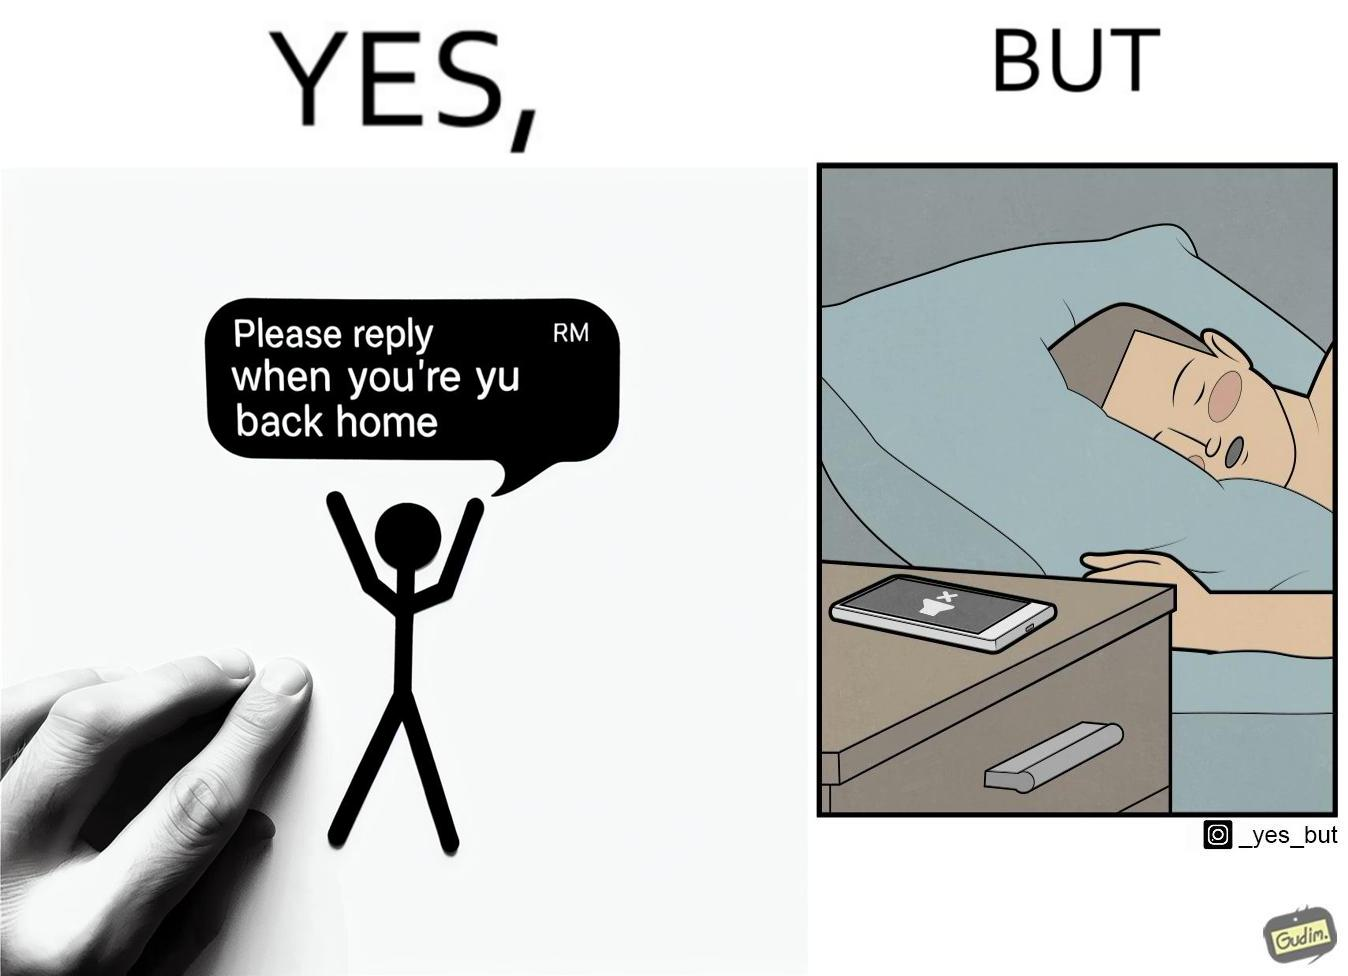Compare the left and right sides of this image. In the left part of the image: It is a text message asking the recipient to reply back once he/she returns home In the right part of the image: It is a man sleeping on his bed with his phone on silent mode 